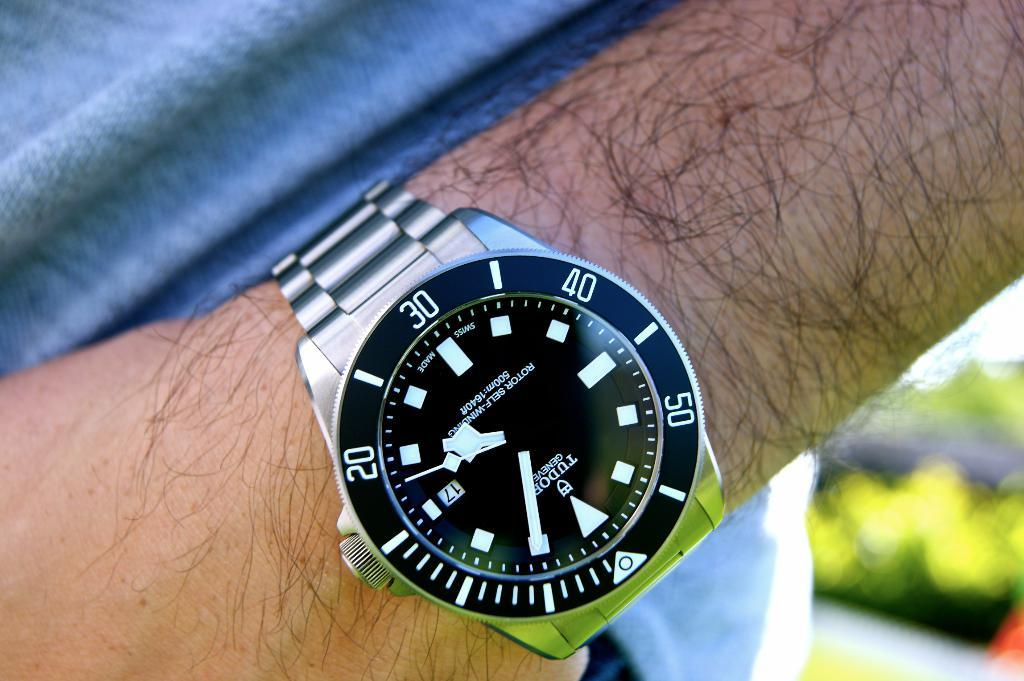<image>
Give a short and clear explanation of the subsequent image. A black and silver Tudor Geneve rests on someone's wrist. 